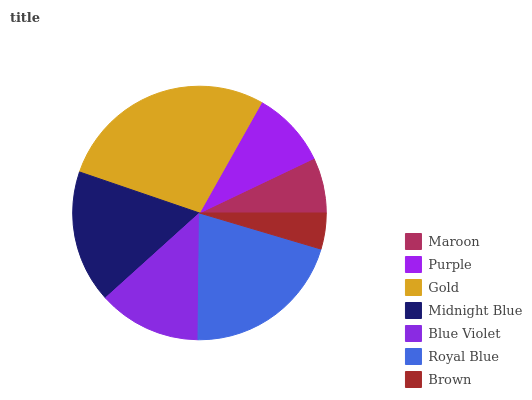Is Brown the minimum?
Answer yes or no. Yes. Is Gold the maximum?
Answer yes or no. Yes. Is Purple the minimum?
Answer yes or no. No. Is Purple the maximum?
Answer yes or no. No. Is Purple greater than Maroon?
Answer yes or no. Yes. Is Maroon less than Purple?
Answer yes or no. Yes. Is Maroon greater than Purple?
Answer yes or no. No. Is Purple less than Maroon?
Answer yes or no. No. Is Blue Violet the high median?
Answer yes or no. Yes. Is Blue Violet the low median?
Answer yes or no. Yes. Is Brown the high median?
Answer yes or no. No. Is Brown the low median?
Answer yes or no. No. 